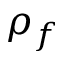Convert formula to latex. <formula><loc_0><loc_0><loc_500><loc_500>\rho _ { f }</formula> 